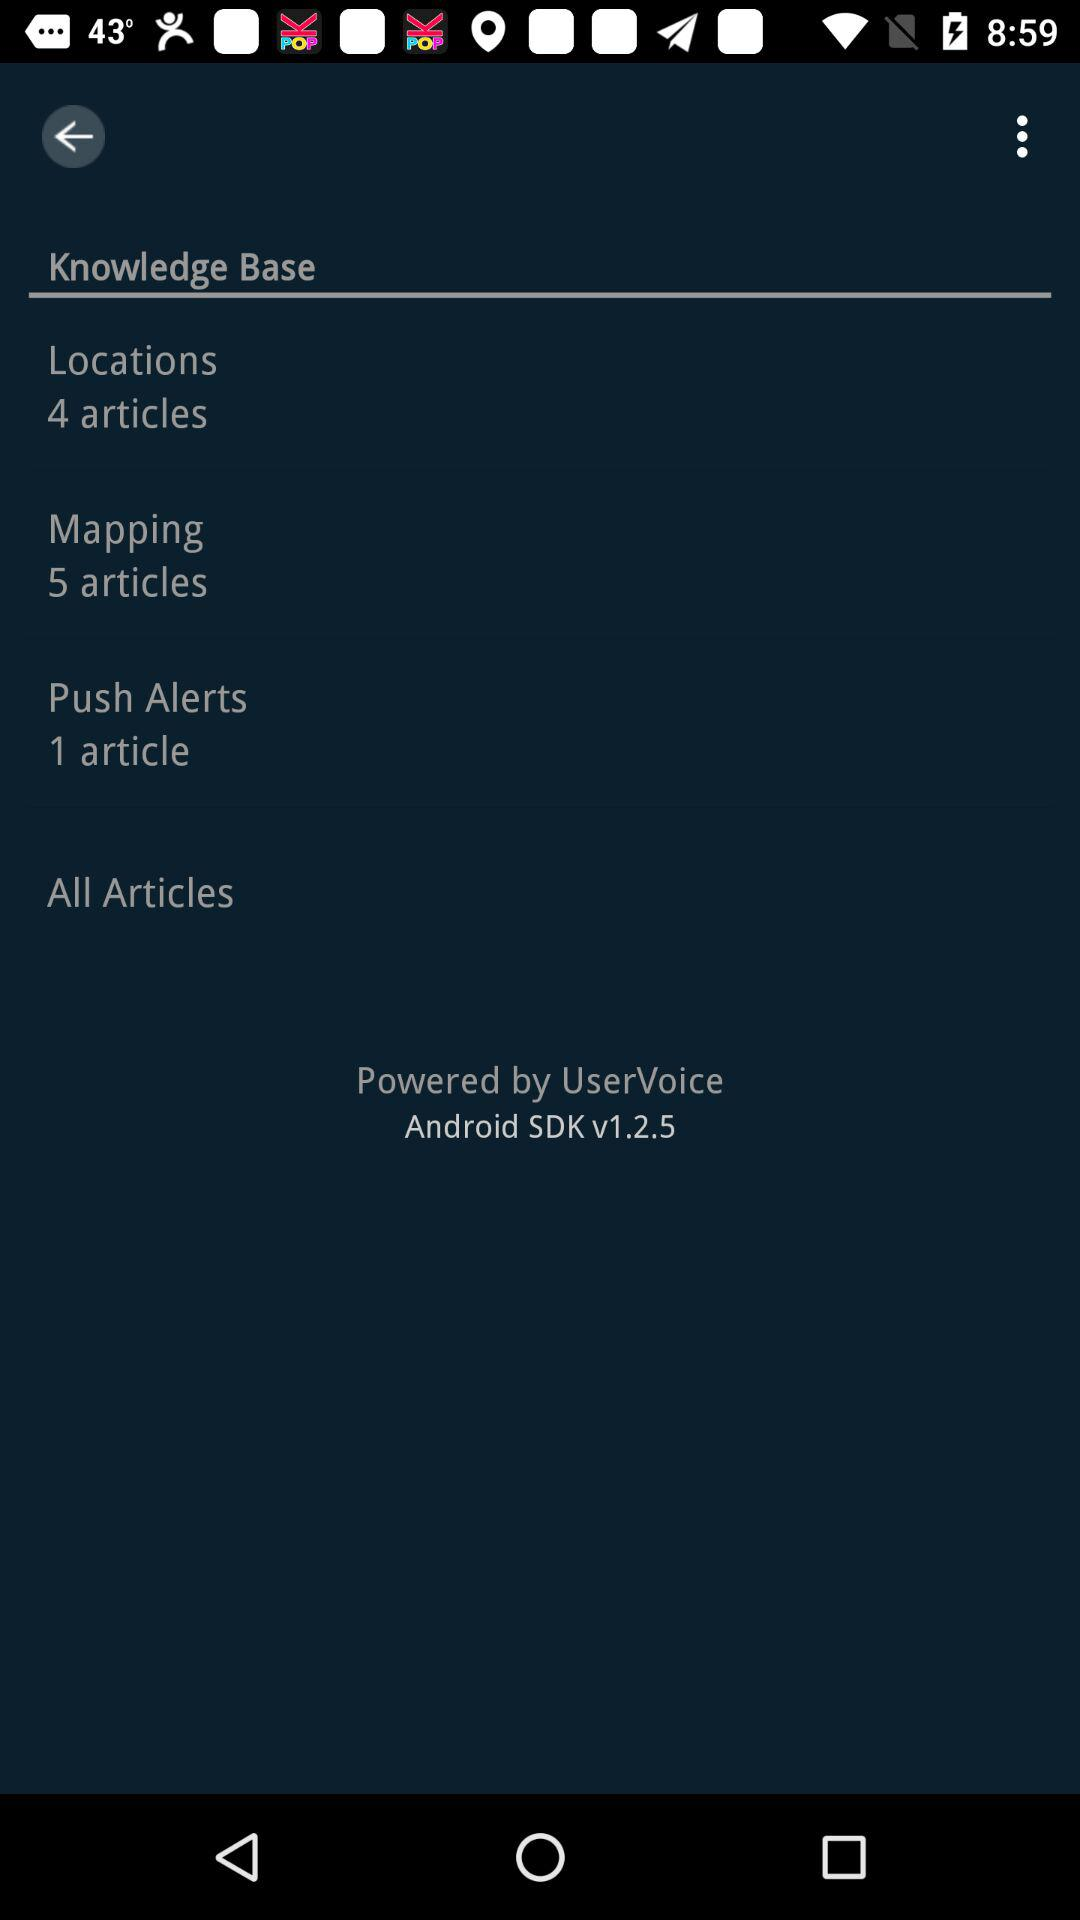What's the Android SDK version? The Android SDK version is v1.2.5. 